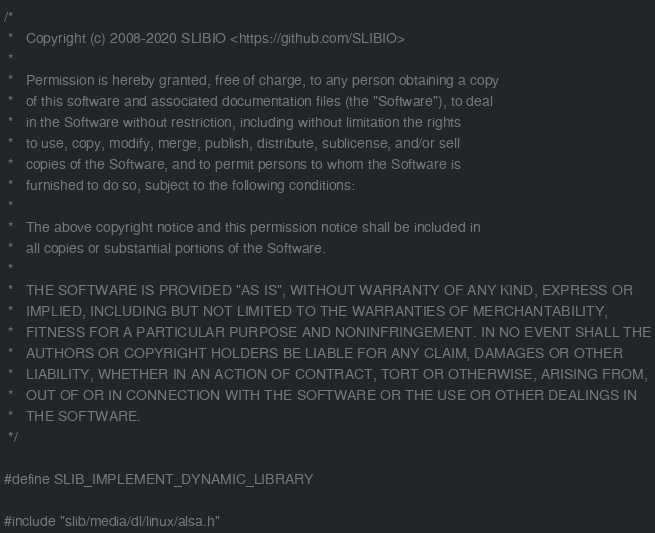<code> <loc_0><loc_0><loc_500><loc_500><_C++_>/*
 *   Copyright (c) 2008-2020 SLIBIO <https://github.com/SLIBIO>
 *
 *   Permission is hereby granted, free of charge, to any person obtaining a copy
 *   of this software and associated documentation files (the "Software"), to deal
 *   in the Software without restriction, including without limitation the rights
 *   to use, copy, modify, merge, publish, distribute, sublicense, and/or sell
 *   copies of the Software, and to permit persons to whom the Software is
 *   furnished to do so, subject to the following conditions:
 *
 *   The above copyright notice and this permission notice shall be included in
 *   all copies or substantial portions of the Software.
 *
 *   THE SOFTWARE IS PROVIDED "AS IS", WITHOUT WARRANTY OF ANY KIND, EXPRESS OR
 *   IMPLIED, INCLUDING BUT NOT LIMITED TO THE WARRANTIES OF MERCHANTABILITY,
 *   FITNESS FOR A PARTICULAR PURPOSE AND NONINFRINGEMENT. IN NO EVENT SHALL THE
 *   AUTHORS OR COPYRIGHT HOLDERS BE LIABLE FOR ANY CLAIM, DAMAGES OR OTHER
 *   LIABILITY, WHETHER IN AN ACTION OF CONTRACT, TORT OR OTHERWISE, ARISING FROM,
 *   OUT OF OR IN CONNECTION WITH THE SOFTWARE OR THE USE OR OTHER DEALINGS IN
 *   THE SOFTWARE.
 */

#define SLIB_IMPLEMENT_DYNAMIC_LIBRARY

#include "slib/media/dl/linux/alsa.h"
</code> 